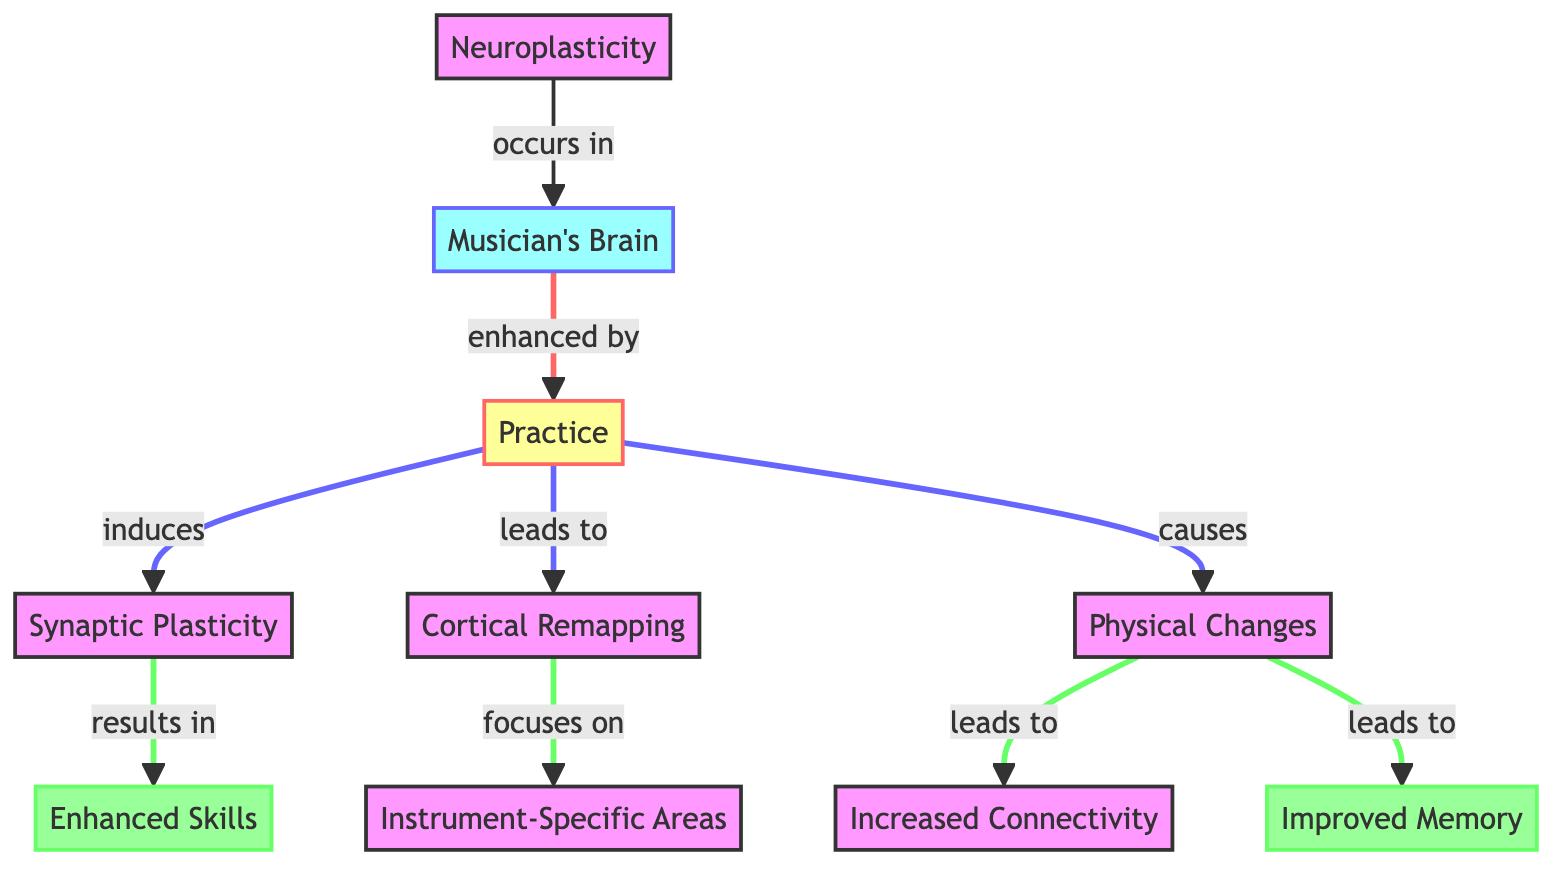What is the main concept illustrated in the diagram? The diagram centers around the main concept of neuroplasticity, which indicates how the brain adapts and changes in response to experiences, especially through practice. This can be inferred from the first node labeled "Neuroplasticity."
Answer: Neuroplasticity How many major nodes are present in the diagram? By counting the distinct nodes, we identify 10 major components including "Neuroplasticity," "Musician's Brain," "Practice," and others. This totals 10 nodes according to the diagram layout.
Answer: 10 What effect does practice have on the musician's brain? The diagram shows that practice enhances the musician's brain, leading to various effects such as synaptic plasticity, cortical remapping, and physical changes, establishing a clear link from practice to these outcomes.
Answer: Enhanced What specific area does cortical remapping focus on? The cortical remapping specifically focuses on "Instrument-Specific Areas" as indicated by the direct link from the "Cortical Remapping" node. This highlights the direct relationship between remapping and the areas designated for specific instruments.
Answer: Instrument-Specific Areas What two outcomes result from physical changes in the musician's brain? Observing the diagram, the physical changes lead to both "Increased Connectivity" and "Improved Memory," as indicated by the branching from the "Physical Changes" node.
Answer: Increased Connectivity, Improved Memory What is the final outcome of increased synaptic plasticity as per the diagram? The diagram illustrates that the final outcome of increased synaptic plasticity is the enhancement of skills, which is explicitly stated as the result of synaptic plasticity along the flow.
Answer: Enhanced Skills How is practice related to improved memory? According to the flow of the diagram, practice indirectly leads to improved memory through the physical changes in the brain, highlighting the causal connection established through practice to different outcomes.
Answer: Through physical changes Which components are directly linked to the concept of "Musician's Brain"? The "Musician's Brain" is directly linked to "Practice," as indicated by the arrow in the diagram, which shows that the musician's brain is enhanced specifically by the act of practice.
Answer: Practice What induces synaptic plasticity? The diagram indicates that synaptic plasticity is induced by practice, shown through the direct link from the "Practice" node to the "Synaptic Plasticity" node, highlighting the role of practice in this process.
Answer: Practice 